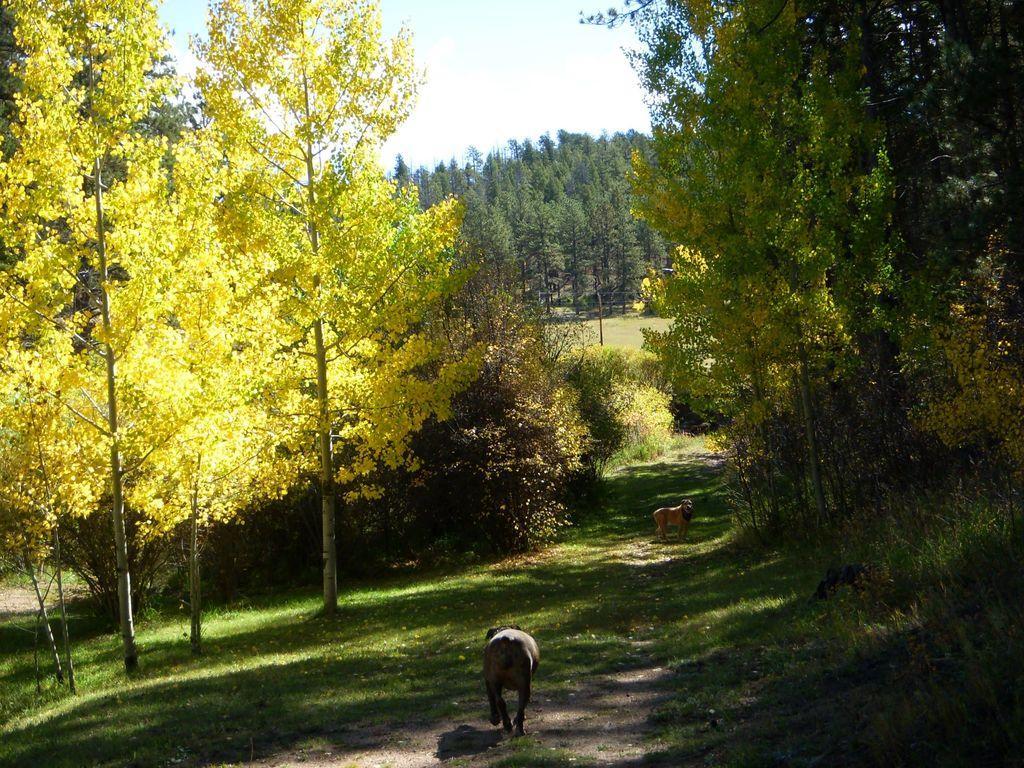Could you give a brief overview of what you see in this image? In this image I can see animals on the ground. In the background I can see the grass, trees and the sky. 